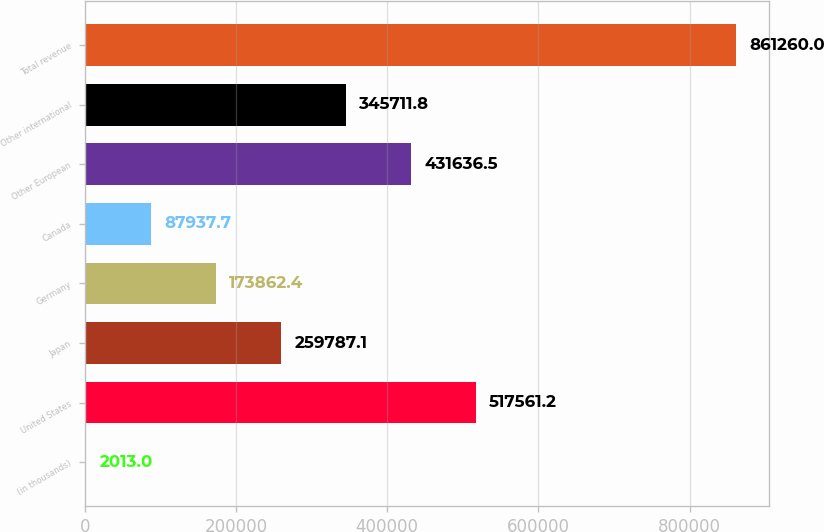Convert chart to OTSL. <chart><loc_0><loc_0><loc_500><loc_500><bar_chart><fcel>(in thousands)<fcel>United States<fcel>Japan<fcel>Germany<fcel>Canada<fcel>Other European<fcel>Other international<fcel>Total revenue<nl><fcel>2013<fcel>517561<fcel>259787<fcel>173862<fcel>87937.7<fcel>431636<fcel>345712<fcel>861260<nl></chart> 